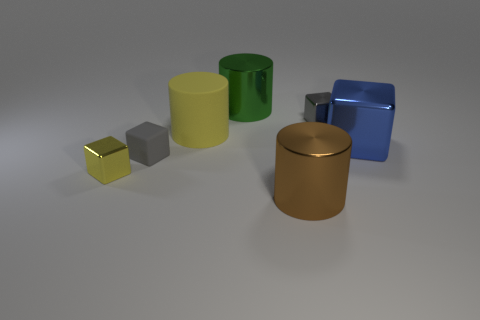Subtract 2 blocks. How many blocks are left? 2 Subtract all small gray shiny cubes. How many cubes are left? 3 Subtract all cubes. How many objects are left? 3 Add 2 big brown things. How many big brown things exist? 3 Add 1 red shiny spheres. How many objects exist? 8 Subtract all yellow cylinders. How many cylinders are left? 2 Subtract 0 red spheres. How many objects are left? 7 Subtract all purple cylinders. Subtract all brown balls. How many cylinders are left? 3 Subtract all gray cylinders. How many blue cubes are left? 1 Subtract all purple rubber cylinders. Subtract all blue blocks. How many objects are left? 6 